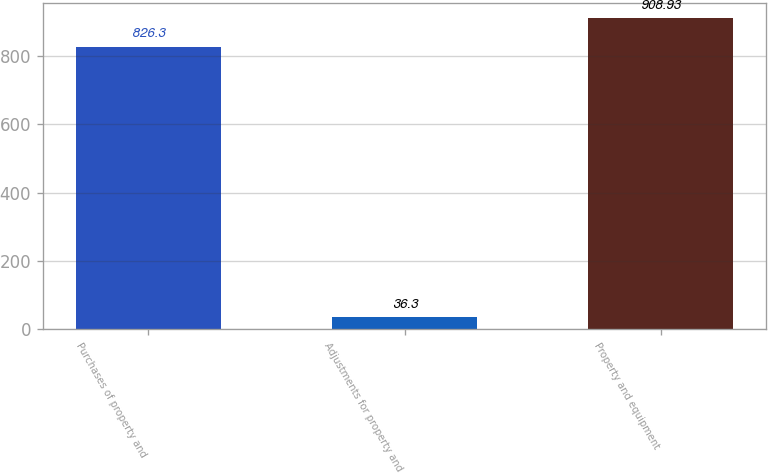<chart> <loc_0><loc_0><loc_500><loc_500><bar_chart><fcel>Purchases of property and<fcel>Adjustments for property and<fcel>Property and equipment<nl><fcel>826.3<fcel>36.3<fcel>908.93<nl></chart> 